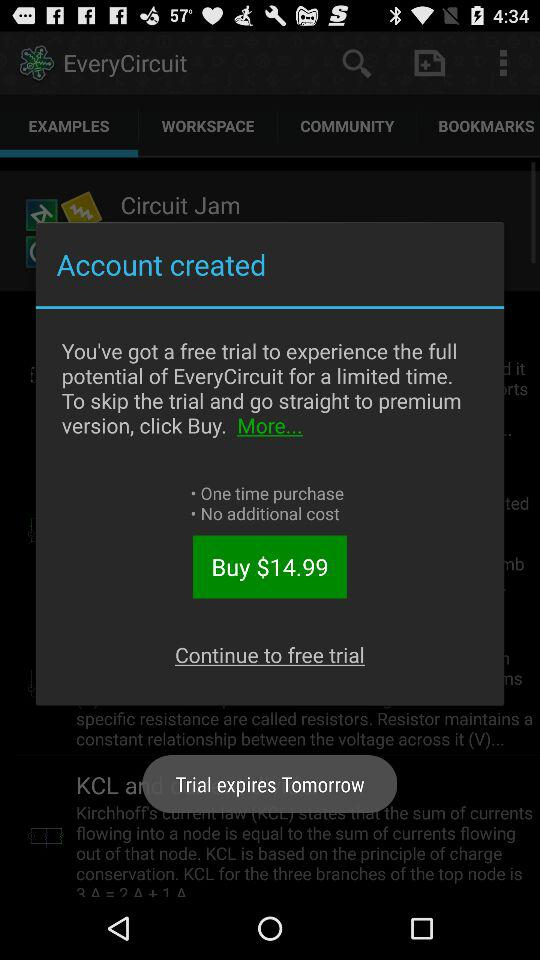How many days are left in my free trial?
Answer the question using a single word or phrase. Tomorrow 